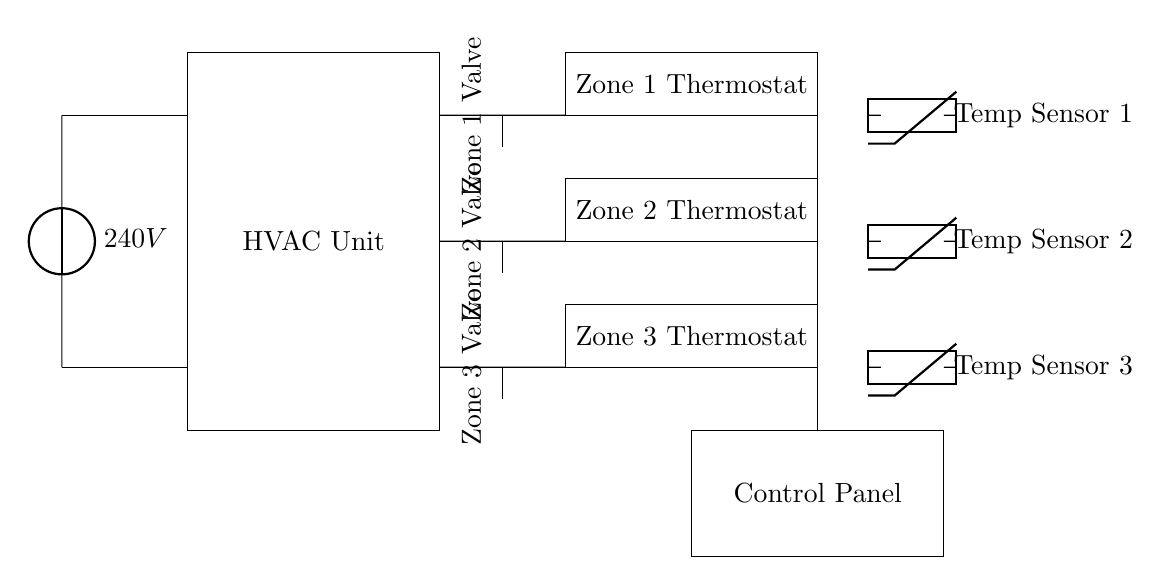What is the main component depicted in the diagram? The main component is the HVAC Unit, which is represented by a rectangle at the center of the diagram. It serves as the primary system component to control heating, ventilation, and air conditioning.
Answer: HVAC Unit What voltage does the power supply provide? The power supply is labeled as providing 240 volts, which is standard for residential HVAC systems in many regions. This information is clearly indicated next to the voltage source symbol in the diagram.
Answer: 240V How many thermostats are shown in the circuit? There are three thermostats depicted, each controlling a separate zone within the HVAC system. This is evident from the labeled rectangles for Zone 1, Zone 2, and Zone 3 thermostats in the diagram.
Answer: Three What type of sensors are included in the design? The sensors included are thermistors, which are used to measure temperature. The diagram shows three thermistors, one associated with each thermostat for temperature sensing and control.
Answer: Thermistors What is the purpose of the control panel in this circuit? The control panel allows users to interact with the HVAC system, potentially adjusting settings or programming zones. It is visually represented as a rectangle at the bottom right corner of the diagram, connecting with the rest of the circuit.
Answer: User interaction Which components are used for zone control? The valves are the components responsible for zone control, as indicated beside each thermostat in the diagram. They regulate the flow of the HVAC system to each designated zone based on thermostat input.
Answer: Valves 